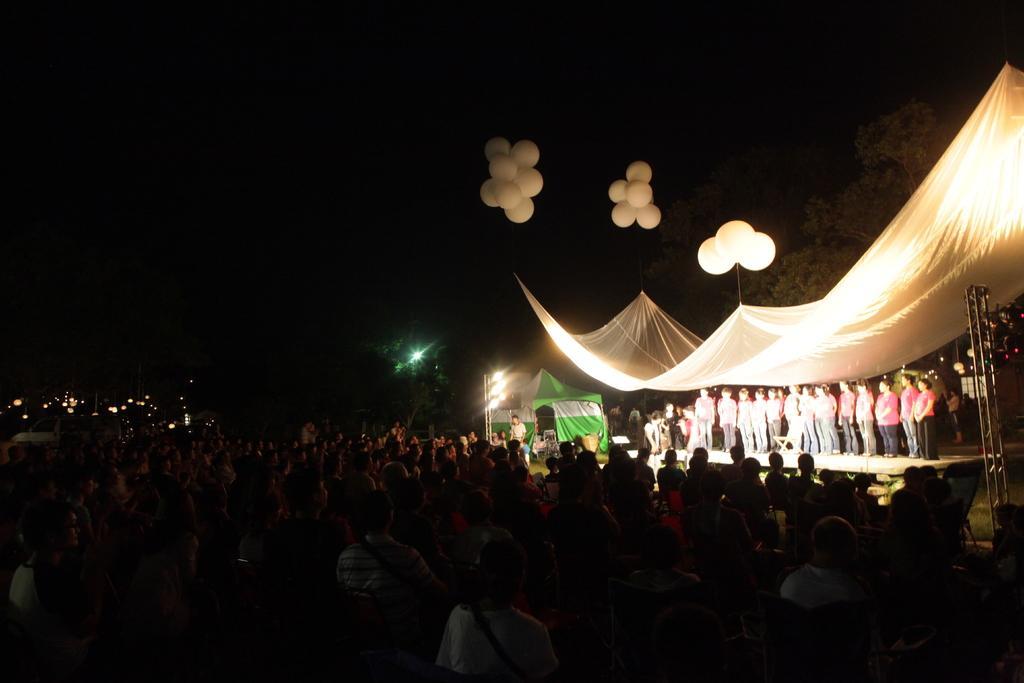Could you give a brief overview of what you see in this image? This is an image clicked in the dark. On the right side I can see few people are standing on the stage. At the top of them I can see a tent. On the left side a crowd of people standing in the dark and looking at the people who are on the stage. At the top I can see few balloons. 